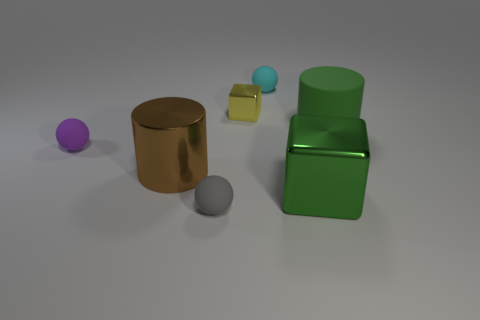There is a tiny purple object; is its shape the same as the thing that is in front of the large green metal block? yes 